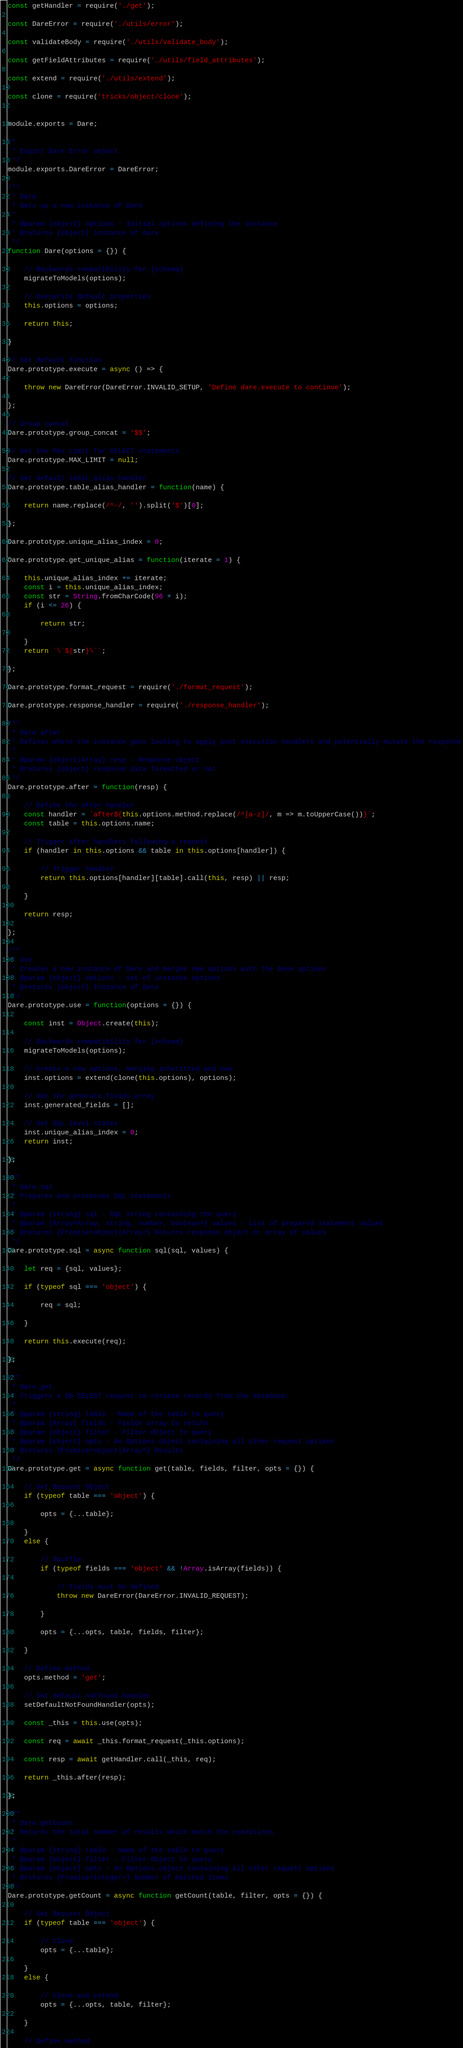<code> <loc_0><loc_0><loc_500><loc_500><_JavaScript_>

const getHandler = require('./get');

const DareError = require('./utils/error');

const validateBody = require('./utils/validate_body');

const getFieldAttributes = require('./utils/field_attributes');

const extend = require('./utils/extend');

const clone = require('tricks/object/clone');


module.exports = Dare;

/*
 * Export Dare Error object
 */
module.exports.DareError = DareError;

/**
 * Dare
 * Sets up a new instance of Dare
 *
 * @param {object} options - Initial options defining the instance
 * @returns {object} instance of dare
 */
function Dare(options = {}) {

	// Backwards compatibility for {schema}
	migrateToModels(options);

	// Overwrite default properties
	this.options = options;

	return this;

}

// Set default function
Dare.prototype.execute = async () => {

	throw new DareError(DareError.INVALID_SETUP, 'Define dare.execute to continue');

};

// Group concat
Dare.prototype.group_concat = '$$';

// Set the Max Limit for SELECT statements
Dare.prototype.MAX_LIMIT = null;

// Set default table_alias handler
Dare.prototype.table_alias_handler = function(name) {

	return name.replace(/^-/, '').split('$')[0];

};

Dare.prototype.unique_alias_index = 0;

Dare.prototype.get_unique_alias = function(iterate = 1) {

	this.unique_alias_index += iterate;
	const i = this.unique_alias_index;
	const str = String.fromCharCode(96 + i);
	if (i <= 26) {

		return str;

	}
	return `\`${str}\``;

};

Dare.prototype.format_request = require('./format_request');

Dare.prototype.response_handler = require('./response_handler');

/**
 * Dare.after
 * Defines where the instance goes looking to apply post execution handlers and potentially mutate the response
 *
 * @param {object|Array} resp - Response object
 * @returns {object} response data formatted or not
 */
Dare.prototype.after = function(resp) {

	// Define the after handler
	const handler = `after${this.options.method.replace(/^[a-z]/, m => m.toUpperCase())}`;
	const table = this.options.name;

	// Trigger after handlers following a request
	if (handler in this.options && table in this.options[handler]) {

		// Trigger handler
		return this.options[handler][table].call(this, resp) || resp;

	}

	return resp;

};

/**
 * Use
 * Creates a new instance of Dare and merges new options with the base options
 * @param {object} options - set of instance options
 * @returns {object} Instance of Dare
 */
Dare.prototype.use = function(options = {}) {

	const inst = Object.create(this);

	// Backwards compatibility for {schema}
	migrateToModels(options);

	// Create a new options, merging inheritted and new
	inst.options = extend(clone(this.options), options);

	// Set the generate_fields array
	inst.generated_fields = [];

	// Set SQL level states
	inst.unique_alias_index = 0;
	return inst;

};

/**
 * Dare.sql
 * Prepares and processes SQL statements
 *
 * @param {string} sql - SQL string containing the query
 * @param {Array<Array, string, number, boolean>} values - List of prepared statement values
 * @returns {Promise<object|Array>} Returns response object or array of values
 */
Dare.prototype.sql = async function sql(sql, values) {

	let req = {sql, values};

	if (typeof sql === 'object') {

		req = sql;

	}

	return this.execute(req);

};

/**
 * Dare.get
 * Triggers a DB SELECT request to rerieve records from the database.
 *
 * @param {string} table - Name of the table to query
 * @param {Array} fields - Fields array to return
 * @param {object} filter - Filter Object to query
 * @param {object} opts - An Options object containing all other request options
 * @returns {Promise<object|Array>} Results
 */
Dare.prototype.get = async function get(table, fields, filter, opts = {}) {

	// Get Request Object
	if (typeof table === 'object') {

		opts = {...table};

	}
	else {

		// Shuffle
		if (typeof fields === 'object' && !Array.isArray(fields)) {

			// Fields must be defined
			throw new DareError(DareError.INVALID_REQUEST);

		}

		opts = {...opts, table, fields, filter};

	}

	// Define method
	opts.method = 'get';

	// Set default notfound handler
	setDefaultNotFoundHandler(opts);

	const _this = this.use(opts);

	const req = await _this.format_request(_this.options);

	const resp = await getHandler.call(_this, req);

	return _this.after(resp);

};

/**
 * Dare.getCount
 * Returns the total number of results which match the conditions
 *
 * @param {string} table - Name of the table to query
 * @param {object} filter - Filter Object to query
 * @param {object} opts - An Options object containing all other request options
 * @returns {Promise<integer>} Number of matched items
 */
Dare.prototype.getCount = async function getCount(table, filter, opts = {}) {

	// Get Request Object
	if (typeof table === 'object') {

		// Clone
		opts = {...table};

	}
	else {

		// Clone and extend
		opts = {...opts, table, filter};

	}

	// Define method</code> 